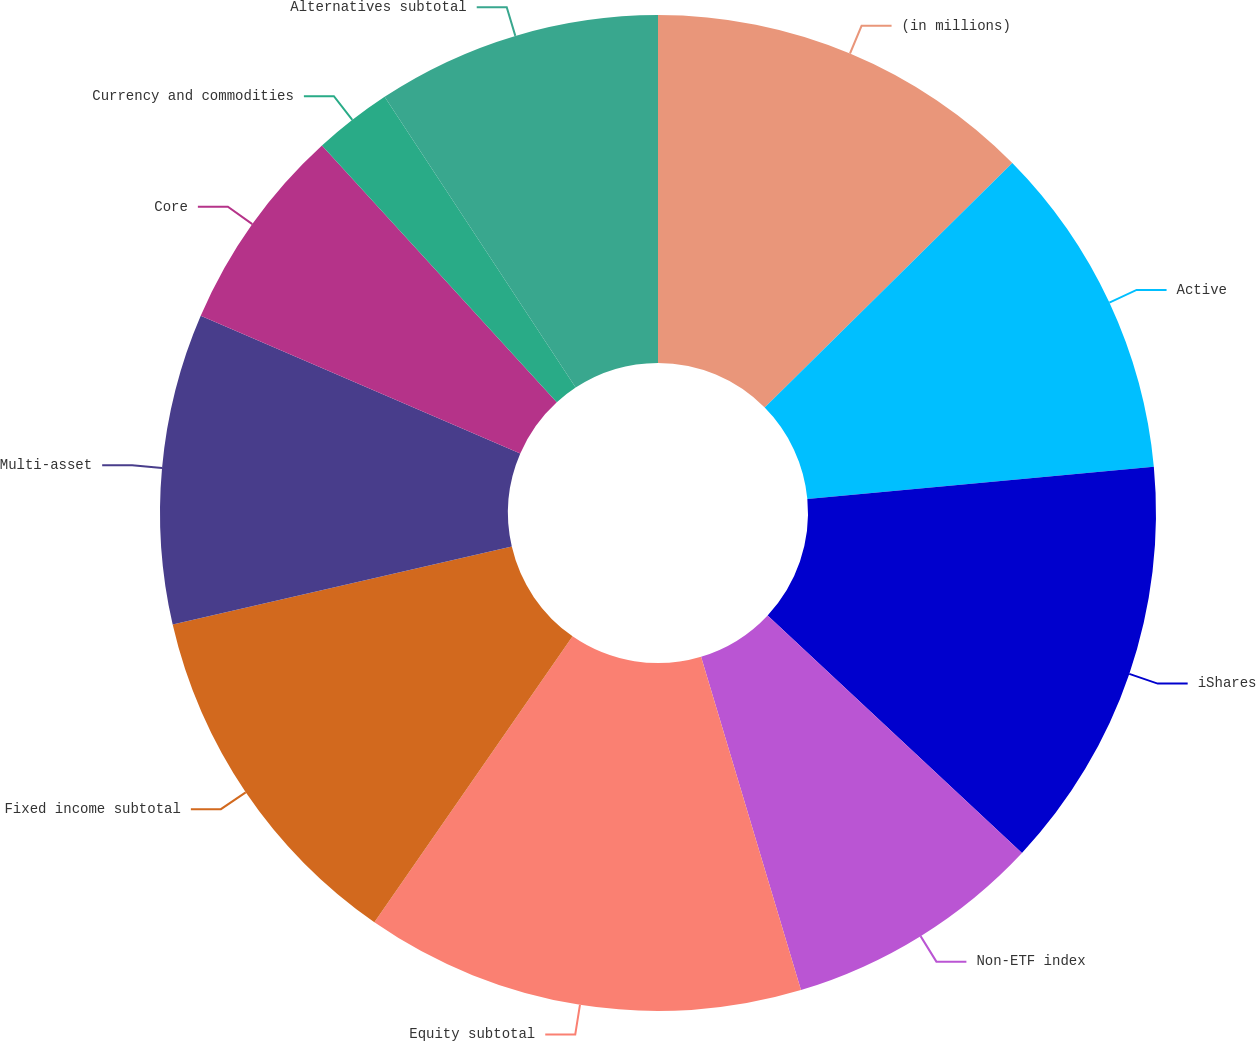Convert chart. <chart><loc_0><loc_0><loc_500><loc_500><pie_chart><fcel>(in millions)<fcel>Active<fcel>iShares<fcel>Non-ETF index<fcel>Equity subtotal<fcel>Fixed income subtotal<fcel>Multi-asset<fcel>Core<fcel>Currency and commodities<fcel>Alternatives subtotal<nl><fcel>12.6%<fcel>10.92%<fcel>13.44%<fcel>8.41%<fcel>14.28%<fcel>11.76%<fcel>10.08%<fcel>6.73%<fcel>2.54%<fcel>9.25%<nl></chart> 